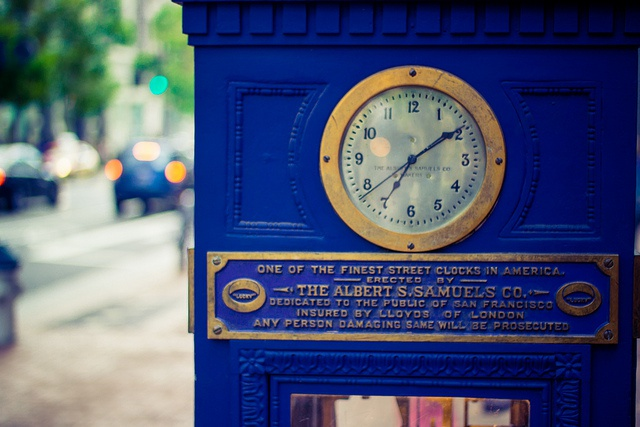Describe the objects in this image and their specific colors. I can see clock in teal, darkgray, gray, and tan tones, car in teal, lightgray, navy, blue, and gray tones, and car in teal, navy, gray, lightgray, and black tones in this image. 